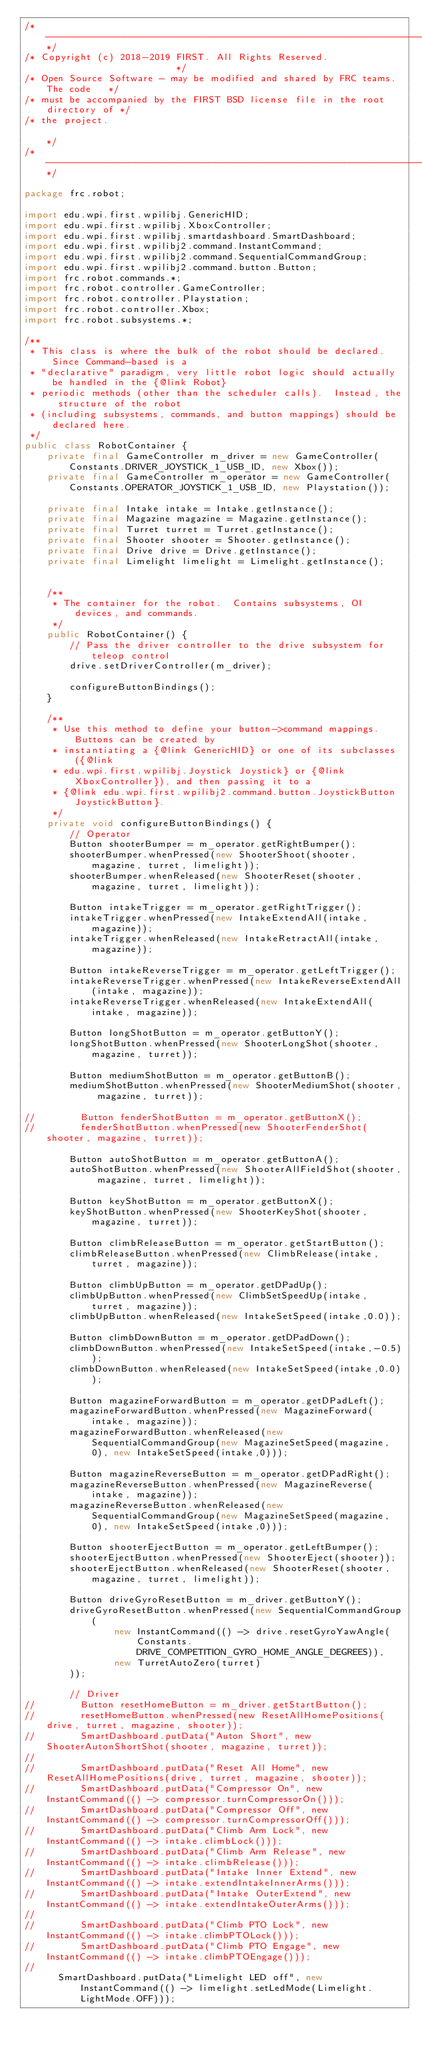<code> <loc_0><loc_0><loc_500><loc_500><_Java_>/*----------------------------------------------------------------------------*/
/* Copyright (c) 2018-2019 FIRST. All Rights Reserved.                        */
/* Open Source Software - may be modified and shared by FRC teams. The code   */
/* must be accompanied by the FIRST BSD license file in the root directory of */
/* the project.                                                               */
/*----------------------------------------------------------------------------*/

package frc.robot;

import edu.wpi.first.wpilibj.GenericHID;
import edu.wpi.first.wpilibj.XboxController;
import edu.wpi.first.wpilibj.smartdashboard.SmartDashboard;
import edu.wpi.first.wpilibj2.command.InstantCommand;
import edu.wpi.first.wpilibj2.command.SequentialCommandGroup;
import edu.wpi.first.wpilibj2.command.button.Button;
import frc.robot.commands.*;
import frc.robot.controller.GameController;
import frc.robot.controller.Playstation;
import frc.robot.controller.Xbox;
import frc.robot.subsystems.*;

/**
 * This class is where the bulk of the robot should be declared.  Since Command-based is a
 * "declarative" paradigm, very little robot logic should actually be handled in the {@link Robot}
 * periodic methods (other than the scheduler calls).  Instead, the structure of the robot
 * (including subsystems, commands, and button mappings) should be declared here.
 */
public class RobotContainer {
    private final GameController m_driver = new GameController(Constants.DRIVER_JOYSTICK_1_USB_ID, new Xbox());
    private final GameController m_operator = new GameController(Constants.OPERATOR_JOYSTICK_1_USB_ID, new Playstation());

    private final Intake intake = Intake.getInstance();
    private final Magazine magazine = Magazine.getInstance();
    private final Turret turret = Turret.getInstance();
    private final Shooter shooter = Shooter.getInstance();
    private final Drive drive = Drive.getInstance();
    private final Limelight limelight = Limelight.getInstance();


    /**
     * The container for the robot.  Contains subsystems, OI devices, and commands.
     */
    public RobotContainer() {
        // Pass the driver controller to the drive subsystem for teleop control
        drive.setDriverController(m_driver);

        configureButtonBindings();
    }

    /**
     * Use this method to define your button->command mappings.  Buttons can be created by
     * instantiating a {@link GenericHID} or one of its subclasses ({@link
     * edu.wpi.first.wpilibj.Joystick Joystick} or {@link XboxController}), and then passing it to a
     * {@link edu.wpi.first.wpilibj2.command.button.JoystickButton JoystickButton}.
     */
    private void configureButtonBindings() {
        // Operator
        Button shooterBumper = m_operator.getRightBumper();
        shooterBumper.whenPressed(new ShooterShoot(shooter, magazine, turret, limelight));
        shooterBumper.whenReleased(new ShooterReset(shooter, magazine, turret, limelight));

        Button intakeTrigger = m_operator.getRightTrigger();
        intakeTrigger.whenPressed(new IntakeExtendAll(intake, magazine));
        intakeTrigger.whenReleased(new IntakeRetractAll(intake, magazine));

        Button intakeReverseTrigger = m_operator.getLeftTrigger();
        intakeReverseTrigger.whenPressed(new IntakeReverseExtendAll(intake, magazine));
        intakeReverseTrigger.whenReleased(new IntakeExtendAll(intake, magazine));

        Button longShotButton = m_operator.getButtonY();
        longShotButton.whenPressed(new ShooterLongShot(shooter, magazine, turret));

        Button mediumShotButton = m_operator.getButtonB();
        mediumShotButton.whenPressed(new ShooterMediumShot(shooter, magazine, turret));

//        Button fenderShotButton = m_operator.getButtonX();
//        fenderShotButton.whenPressed(new ShooterFenderShot(shooter, magazine, turret));

        Button autoShotButton = m_operator.getButtonA();
        autoShotButton.whenPressed(new ShooterAllFieldShot(shooter, magazine, turret, limelight));

        Button keyShotButton = m_operator.getButtonX();
        keyShotButton.whenPressed(new ShooterKeyShot(shooter, magazine, turret));

        Button climbReleaseButton = m_operator.getStartButton();
        climbReleaseButton.whenPressed(new ClimbRelease(intake, turret, magazine));

        Button climbUpButton = m_operator.getDPadUp();
        climbUpButton.whenPressed(new ClimbSetSpeedUp(intake, turret, magazine));
        climbUpButton.whenReleased(new IntakeSetSpeed(intake,0.0));

        Button climbDownButton = m_operator.getDPadDown();
        climbDownButton.whenPressed(new IntakeSetSpeed(intake,-0.5));
        climbDownButton.whenReleased(new IntakeSetSpeed(intake,0.0));

        Button magazineForwardButton = m_operator.getDPadLeft();
        magazineForwardButton.whenPressed(new MagazineForward(intake, magazine));
        magazineForwardButton.whenReleased(new SequentialCommandGroup(new MagazineSetSpeed(magazine, 0), new IntakeSetSpeed(intake,0)));

        Button magazineReverseButton = m_operator.getDPadRight();
        magazineReverseButton.whenPressed(new MagazineReverse(intake, magazine));
        magazineReverseButton.whenReleased(new SequentialCommandGroup(new MagazineSetSpeed(magazine, 0), new IntakeSetSpeed(intake,0)));

        Button shooterEjectButton = m_operator.getLeftBumper();
        shooterEjectButton.whenPressed(new ShooterEject(shooter));
        shooterEjectButton.whenReleased(new ShooterReset(shooter, magazine, turret, limelight));

        Button driveGyroResetButton = m_driver.getButtonY();
        driveGyroResetButton.whenPressed(new SequentialCommandGroup(
                new InstantCommand(() -> drive.resetGyroYawAngle(Constants.DRIVE_COMPETITION_GYRO_HOME_ANGLE_DEGREES)),
                new TurretAutoZero(turret)
        ));

        // Driver
//        Button resetHomeButton = m_driver.getStartButton();
//        resetHomeButton.whenPressed(new ResetAllHomePositions(drive, turret, magazine, shooter));
//        SmartDashboard.putData("Auton Short", new ShooterAutonShortShot(shooter, magazine, turret));
//
//        SmartDashboard.putData("Reset All Home", new ResetAllHomePositions(drive, turret, magazine, shooter));
//        SmartDashboard.putData("Compressor On", new InstantCommand(() -> compressor.turnCompressorOn()));
//        SmartDashboard.putData("Compressor Off", new InstantCommand(() -> compressor.turnCompressorOff()));
//        SmartDashboard.putData("Climb Arm Lock", new InstantCommand(() -> intake.climbLock()));
//        SmartDashboard.putData("Climb Arm Release", new InstantCommand(() -> intake.climbRelease()));
//        SmartDashboard.putData("Intake Inner Extend", new InstantCommand(() -> intake.extendIntakeInnerArms()));
//        SmartDashboard.putData("Intake OuterExtend", new InstantCommand(() -> intake.extendIntakeOuterArms()));
//
//        SmartDashboard.putData("Climb PTO Lock", new InstantCommand(() -> intake.climbPTOLock()));
//        SmartDashboard.putData("Climb PTO Engage", new InstantCommand(() -> intake.climbPTOEngage()));
//
      SmartDashboard.putData("Limelight LED off", new InstantCommand(() -> limelight.setLedMode(Limelight.LightMode.OFF)));</code> 